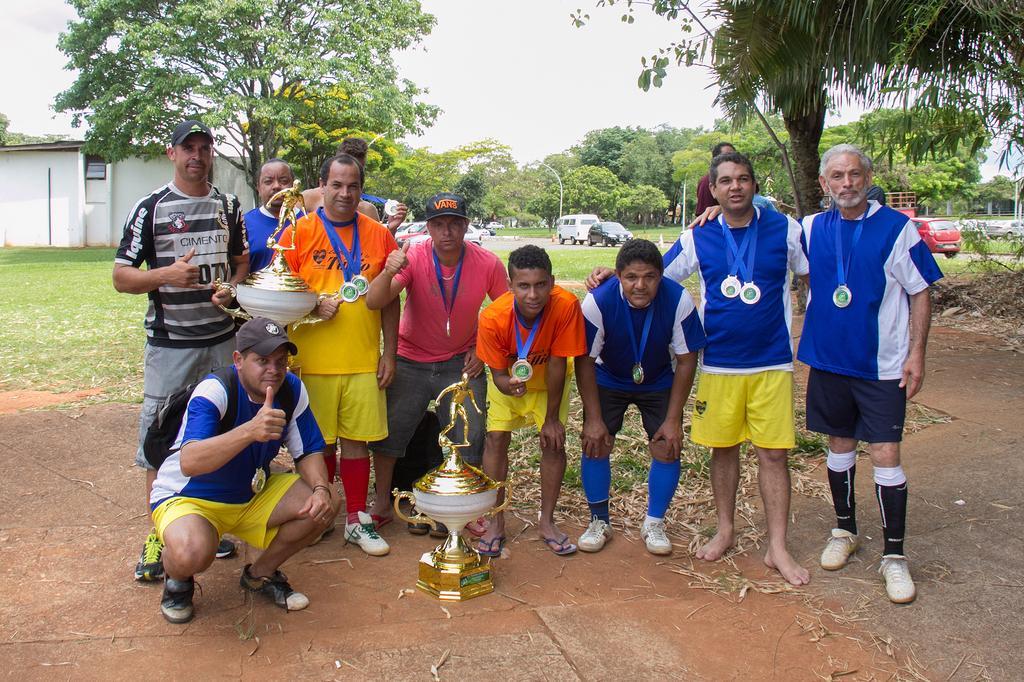Please provide a concise description of this image. In this image, we can see a cup and there are people wearing medals and holding a cup. In the background, there are trees, poles, shed and we can see vehicles on the road. At the bottom, there is ground and at the top, there is sky. 